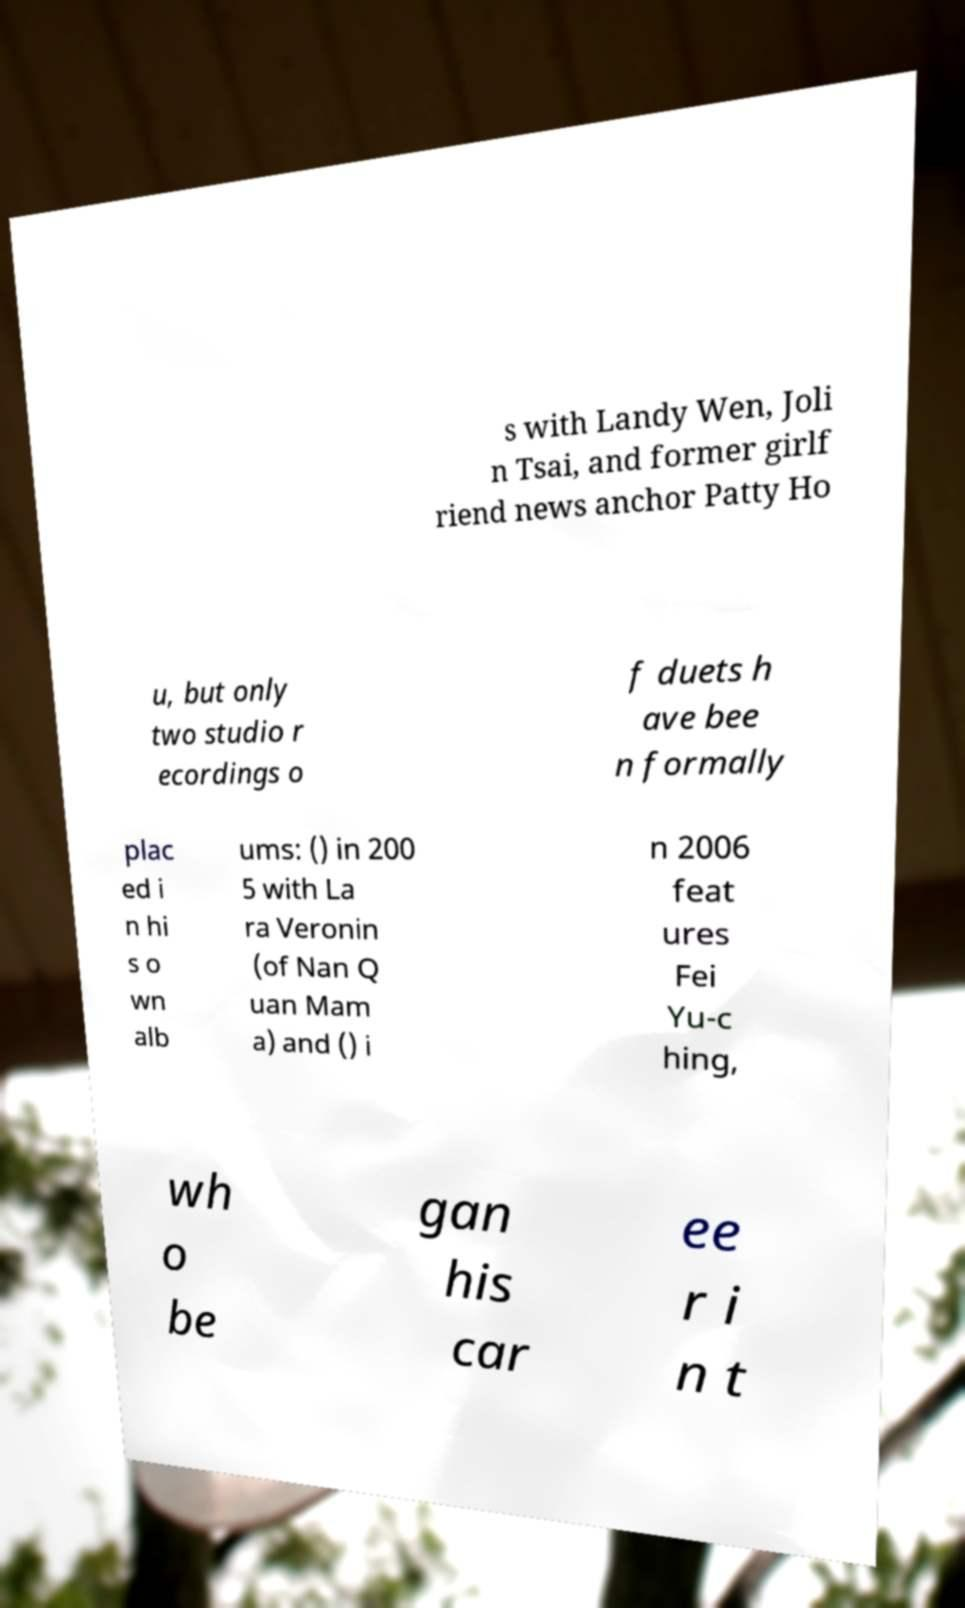Could you extract and type out the text from this image? s with Landy Wen, Joli n Tsai, and former girlf riend news anchor Patty Ho u, but only two studio r ecordings o f duets h ave bee n formally plac ed i n hi s o wn alb ums: () in 200 5 with La ra Veronin (of Nan Q uan Mam a) and () i n 2006 feat ures Fei Yu-c hing, wh o be gan his car ee r i n t 